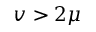Convert formula to latex. <formula><loc_0><loc_0><loc_500><loc_500>v > 2 \mu</formula> 